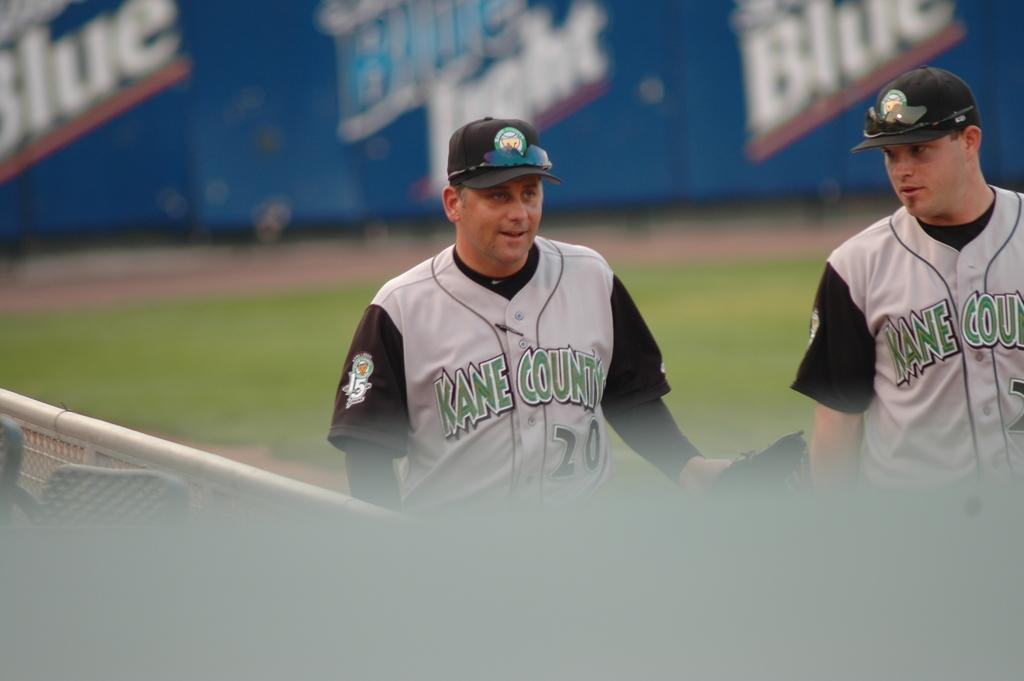<image>
Give a short and clear explanation of the subsequent image. two baseball players wearing jerseys from Kane County 